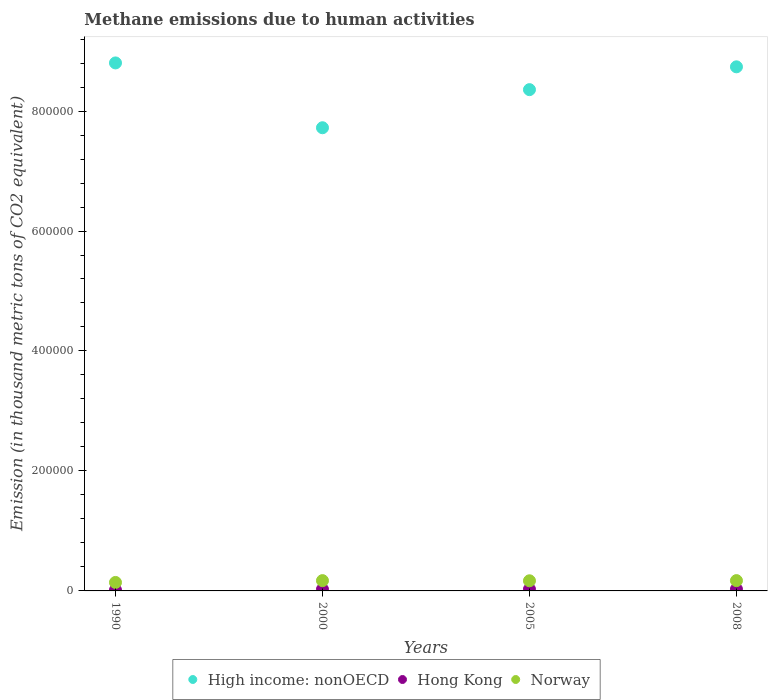How many different coloured dotlines are there?
Offer a terse response. 3. What is the amount of methane emitted in Norway in 2005?
Offer a terse response. 1.69e+04. Across all years, what is the maximum amount of methane emitted in Norway?
Your answer should be compact. 1.72e+04. Across all years, what is the minimum amount of methane emitted in Hong Kong?
Offer a very short reply. 1532.1. In which year was the amount of methane emitted in Norway maximum?
Make the answer very short. 2008. In which year was the amount of methane emitted in Norway minimum?
Make the answer very short. 1990. What is the total amount of methane emitted in Norway in the graph?
Offer a very short reply. 6.53e+04. What is the difference between the amount of methane emitted in High income: nonOECD in 2005 and that in 2008?
Offer a very short reply. -3.80e+04. What is the difference between the amount of methane emitted in Norway in 2000 and the amount of methane emitted in Hong Kong in 2008?
Your answer should be compact. 1.42e+04. What is the average amount of methane emitted in High income: nonOECD per year?
Offer a very short reply. 8.40e+05. In the year 1990, what is the difference between the amount of methane emitted in Norway and amount of methane emitted in Hong Kong?
Keep it short and to the point. 1.26e+04. In how many years, is the amount of methane emitted in High income: nonOECD greater than 560000 thousand metric tons?
Your answer should be compact. 4. What is the ratio of the amount of methane emitted in Hong Kong in 1990 to that in 2000?
Your answer should be very brief. 0.57. Is the amount of methane emitted in Norway in 2000 less than that in 2008?
Provide a succinct answer. Yes. Is the difference between the amount of methane emitted in Norway in 1990 and 2000 greater than the difference between the amount of methane emitted in Hong Kong in 1990 and 2000?
Provide a succinct answer. No. What is the difference between the highest and the lowest amount of methane emitted in Norway?
Keep it short and to the point. 3050.8. In how many years, is the amount of methane emitted in Hong Kong greater than the average amount of methane emitted in Hong Kong taken over all years?
Keep it short and to the point. 3. Is the sum of the amount of methane emitted in High income: nonOECD in 1990 and 2005 greater than the maximum amount of methane emitted in Hong Kong across all years?
Give a very brief answer. Yes. Is it the case that in every year, the sum of the amount of methane emitted in High income: nonOECD and amount of methane emitted in Norway  is greater than the amount of methane emitted in Hong Kong?
Your answer should be very brief. Yes. Is the amount of methane emitted in Norway strictly greater than the amount of methane emitted in Hong Kong over the years?
Your answer should be very brief. Yes. Is the amount of methane emitted in Hong Kong strictly less than the amount of methane emitted in Norway over the years?
Provide a succinct answer. Yes. How many dotlines are there?
Your answer should be very brief. 3. What is the difference between two consecutive major ticks on the Y-axis?
Offer a very short reply. 2.00e+05. Are the values on the major ticks of Y-axis written in scientific E-notation?
Keep it short and to the point. No. How many legend labels are there?
Your answer should be compact. 3. What is the title of the graph?
Provide a succinct answer. Methane emissions due to human activities. Does "Fragile and conflict affected situations" appear as one of the legend labels in the graph?
Keep it short and to the point. No. What is the label or title of the X-axis?
Your answer should be compact. Years. What is the label or title of the Y-axis?
Your answer should be compact. Emission (in thousand metric tons of CO2 equivalent). What is the Emission (in thousand metric tons of CO2 equivalent) in High income: nonOECD in 1990?
Make the answer very short. 8.80e+05. What is the Emission (in thousand metric tons of CO2 equivalent) of Hong Kong in 1990?
Offer a very short reply. 1532.1. What is the Emission (in thousand metric tons of CO2 equivalent) in Norway in 1990?
Ensure brevity in your answer.  1.41e+04. What is the Emission (in thousand metric tons of CO2 equivalent) of High income: nonOECD in 2000?
Your answer should be very brief. 7.72e+05. What is the Emission (in thousand metric tons of CO2 equivalent) in Hong Kong in 2000?
Keep it short and to the point. 2694.6. What is the Emission (in thousand metric tons of CO2 equivalent) in Norway in 2000?
Your response must be concise. 1.72e+04. What is the Emission (in thousand metric tons of CO2 equivalent) of High income: nonOECD in 2005?
Provide a short and direct response. 8.36e+05. What is the Emission (in thousand metric tons of CO2 equivalent) of Hong Kong in 2005?
Offer a very short reply. 2825. What is the Emission (in thousand metric tons of CO2 equivalent) in Norway in 2005?
Your response must be concise. 1.69e+04. What is the Emission (in thousand metric tons of CO2 equivalent) in High income: nonOECD in 2008?
Ensure brevity in your answer.  8.74e+05. What is the Emission (in thousand metric tons of CO2 equivalent) of Hong Kong in 2008?
Your answer should be very brief. 2976.8. What is the Emission (in thousand metric tons of CO2 equivalent) of Norway in 2008?
Give a very brief answer. 1.72e+04. Across all years, what is the maximum Emission (in thousand metric tons of CO2 equivalent) in High income: nonOECD?
Provide a succinct answer. 8.80e+05. Across all years, what is the maximum Emission (in thousand metric tons of CO2 equivalent) of Hong Kong?
Provide a short and direct response. 2976.8. Across all years, what is the maximum Emission (in thousand metric tons of CO2 equivalent) in Norway?
Your answer should be very brief. 1.72e+04. Across all years, what is the minimum Emission (in thousand metric tons of CO2 equivalent) in High income: nonOECD?
Ensure brevity in your answer.  7.72e+05. Across all years, what is the minimum Emission (in thousand metric tons of CO2 equivalent) of Hong Kong?
Offer a terse response. 1532.1. Across all years, what is the minimum Emission (in thousand metric tons of CO2 equivalent) in Norway?
Ensure brevity in your answer.  1.41e+04. What is the total Emission (in thousand metric tons of CO2 equivalent) in High income: nonOECD in the graph?
Provide a short and direct response. 3.36e+06. What is the total Emission (in thousand metric tons of CO2 equivalent) in Hong Kong in the graph?
Give a very brief answer. 1.00e+04. What is the total Emission (in thousand metric tons of CO2 equivalent) of Norway in the graph?
Ensure brevity in your answer.  6.53e+04. What is the difference between the Emission (in thousand metric tons of CO2 equivalent) in High income: nonOECD in 1990 and that in 2000?
Ensure brevity in your answer.  1.08e+05. What is the difference between the Emission (in thousand metric tons of CO2 equivalent) of Hong Kong in 1990 and that in 2000?
Offer a terse response. -1162.5. What is the difference between the Emission (in thousand metric tons of CO2 equivalent) of Norway in 1990 and that in 2000?
Provide a short and direct response. -3029.8. What is the difference between the Emission (in thousand metric tons of CO2 equivalent) in High income: nonOECD in 1990 and that in 2005?
Offer a terse response. 4.45e+04. What is the difference between the Emission (in thousand metric tons of CO2 equivalent) in Hong Kong in 1990 and that in 2005?
Ensure brevity in your answer.  -1292.9. What is the difference between the Emission (in thousand metric tons of CO2 equivalent) in Norway in 1990 and that in 2005?
Make the answer very short. -2775. What is the difference between the Emission (in thousand metric tons of CO2 equivalent) of High income: nonOECD in 1990 and that in 2008?
Offer a very short reply. 6496.2. What is the difference between the Emission (in thousand metric tons of CO2 equivalent) of Hong Kong in 1990 and that in 2008?
Give a very brief answer. -1444.7. What is the difference between the Emission (in thousand metric tons of CO2 equivalent) in Norway in 1990 and that in 2008?
Offer a terse response. -3050.8. What is the difference between the Emission (in thousand metric tons of CO2 equivalent) of High income: nonOECD in 2000 and that in 2005?
Your answer should be very brief. -6.35e+04. What is the difference between the Emission (in thousand metric tons of CO2 equivalent) of Hong Kong in 2000 and that in 2005?
Provide a succinct answer. -130.4. What is the difference between the Emission (in thousand metric tons of CO2 equivalent) of Norway in 2000 and that in 2005?
Offer a terse response. 254.8. What is the difference between the Emission (in thousand metric tons of CO2 equivalent) of High income: nonOECD in 2000 and that in 2008?
Offer a terse response. -1.02e+05. What is the difference between the Emission (in thousand metric tons of CO2 equivalent) of Hong Kong in 2000 and that in 2008?
Keep it short and to the point. -282.2. What is the difference between the Emission (in thousand metric tons of CO2 equivalent) in High income: nonOECD in 2005 and that in 2008?
Provide a short and direct response. -3.80e+04. What is the difference between the Emission (in thousand metric tons of CO2 equivalent) of Hong Kong in 2005 and that in 2008?
Your answer should be compact. -151.8. What is the difference between the Emission (in thousand metric tons of CO2 equivalent) of Norway in 2005 and that in 2008?
Offer a terse response. -275.8. What is the difference between the Emission (in thousand metric tons of CO2 equivalent) in High income: nonOECD in 1990 and the Emission (in thousand metric tons of CO2 equivalent) in Hong Kong in 2000?
Your answer should be compact. 8.78e+05. What is the difference between the Emission (in thousand metric tons of CO2 equivalent) in High income: nonOECD in 1990 and the Emission (in thousand metric tons of CO2 equivalent) in Norway in 2000?
Provide a succinct answer. 8.63e+05. What is the difference between the Emission (in thousand metric tons of CO2 equivalent) of Hong Kong in 1990 and the Emission (in thousand metric tons of CO2 equivalent) of Norway in 2000?
Your answer should be compact. -1.56e+04. What is the difference between the Emission (in thousand metric tons of CO2 equivalent) of High income: nonOECD in 1990 and the Emission (in thousand metric tons of CO2 equivalent) of Hong Kong in 2005?
Offer a very short reply. 8.77e+05. What is the difference between the Emission (in thousand metric tons of CO2 equivalent) of High income: nonOECD in 1990 and the Emission (in thousand metric tons of CO2 equivalent) of Norway in 2005?
Provide a short and direct response. 8.63e+05. What is the difference between the Emission (in thousand metric tons of CO2 equivalent) of Hong Kong in 1990 and the Emission (in thousand metric tons of CO2 equivalent) of Norway in 2005?
Offer a very short reply. -1.54e+04. What is the difference between the Emission (in thousand metric tons of CO2 equivalent) of High income: nonOECD in 1990 and the Emission (in thousand metric tons of CO2 equivalent) of Hong Kong in 2008?
Ensure brevity in your answer.  8.77e+05. What is the difference between the Emission (in thousand metric tons of CO2 equivalent) in High income: nonOECD in 1990 and the Emission (in thousand metric tons of CO2 equivalent) in Norway in 2008?
Offer a terse response. 8.63e+05. What is the difference between the Emission (in thousand metric tons of CO2 equivalent) in Hong Kong in 1990 and the Emission (in thousand metric tons of CO2 equivalent) in Norway in 2008?
Your answer should be very brief. -1.56e+04. What is the difference between the Emission (in thousand metric tons of CO2 equivalent) of High income: nonOECD in 2000 and the Emission (in thousand metric tons of CO2 equivalent) of Hong Kong in 2005?
Your answer should be compact. 7.69e+05. What is the difference between the Emission (in thousand metric tons of CO2 equivalent) of High income: nonOECD in 2000 and the Emission (in thousand metric tons of CO2 equivalent) of Norway in 2005?
Your response must be concise. 7.55e+05. What is the difference between the Emission (in thousand metric tons of CO2 equivalent) of Hong Kong in 2000 and the Emission (in thousand metric tons of CO2 equivalent) of Norway in 2005?
Provide a short and direct response. -1.42e+04. What is the difference between the Emission (in thousand metric tons of CO2 equivalent) in High income: nonOECD in 2000 and the Emission (in thousand metric tons of CO2 equivalent) in Hong Kong in 2008?
Give a very brief answer. 7.69e+05. What is the difference between the Emission (in thousand metric tons of CO2 equivalent) of High income: nonOECD in 2000 and the Emission (in thousand metric tons of CO2 equivalent) of Norway in 2008?
Ensure brevity in your answer.  7.55e+05. What is the difference between the Emission (in thousand metric tons of CO2 equivalent) in Hong Kong in 2000 and the Emission (in thousand metric tons of CO2 equivalent) in Norway in 2008?
Your response must be concise. -1.45e+04. What is the difference between the Emission (in thousand metric tons of CO2 equivalent) in High income: nonOECD in 2005 and the Emission (in thousand metric tons of CO2 equivalent) in Hong Kong in 2008?
Your answer should be very brief. 8.33e+05. What is the difference between the Emission (in thousand metric tons of CO2 equivalent) in High income: nonOECD in 2005 and the Emission (in thousand metric tons of CO2 equivalent) in Norway in 2008?
Ensure brevity in your answer.  8.18e+05. What is the difference between the Emission (in thousand metric tons of CO2 equivalent) of Hong Kong in 2005 and the Emission (in thousand metric tons of CO2 equivalent) of Norway in 2008?
Your answer should be compact. -1.43e+04. What is the average Emission (in thousand metric tons of CO2 equivalent) of High income: nonOECD per year?
Keep it short and to the point. 8.40e+05. What is the average Emission (in thousand metric tons of CO2 equivalent) of Hong Kong per year?
Ensure brevity in your answer.  2507.12. What is the average Emission (in thousand metric tons of CO2 equivalent) of Norway per year?
Keep it short and to the point. 1.63e+04. In the year 1990, what is the difference between the Emission (in thousand metric tons of CO2 equivalent) of High income: nonOECD and Emission (in thousand metric tons of CO2 equivalent) of Hong Kong?
Your answer should be compact. 8.79e+05. In the year 1990, what is the difference between the Emission (in thousand metric tons of CO2 equivalent) of High income: nonOECD and Emission (in thousand metric tons of CO2 equivalent) of Norway?
Provide a short and direct response. 8.66e+05. In the year 1990, what is the difference between the Emission (in thousand metric tons of CO2 equivalent) in Hong Kong and Emission (in thousand metric tons of CO2 equivalent) in Norway?
Your response must be concise. -1.26e+04. In the year 2000, what is the difference between the Emission (in thousand metric tons of CO2 equivalent) in High income: nonOECD and Emission (in thousand metric tons of CO2 equivalent) in Hong Kong?
Provide a short and direct response. 7.69e+05. In the year 2000, what is the difference between the Emission (in thousand metric tons of CO2 equivalent) in High income: nonOECD and Emission (in thousand metric tons of CO2 equivalent) in Norway?
Make the answer very short. 7.55e+05. In the year 2000, what is the difference between the Emission (in thousand metric tons of CO2 equivalent) in Hong Kong and Emission (in thousand metric tons of CO2 equivalent) in Norway?
Offer a terse response. -1.45e+04. In the year 2005, what is the difference between the Emission (in thousand metric tons of CO2 equivalent) of High income: nonOECD and Emission (in thousand metric tons of CO2 equivalent) of Hong Kong?
Make the answer very short. 8.33e+05. In the year 2005, what is the difference between the Emission (in thousand metric tons of CO2 equivalent) in High income: nonOECD and Emission (in thousand metric tons of CO2 equivalent) in Norway?
Make the answer very short. 8.19e+05. In the year 2005, what is the difference between the Emission (in thousand metric tons of CO2 equivalent) in Hong Kong and Emission (in thousand metric tons of CO2 equivalent) in Norway?
Offer a very short reply. -1.41e+04. In the year 2008, what is the difference between the Emission (in thousand metric tons of CO2 equivalent) in High income: nonOECD and Emission (in thousand metric tons of CO2 equivalent) in Hong Kong?
Make the answer very short. 8.71e+05. In the year 2008, what is the difference between the Emission (in thousand metric tons of CO2 equivalent) of High income: nonOECD and Emission (in thousand metric tons of CO2 equivalent) of Norway?
Provide a succinct answer. 8.57e+05. In the year 2008, what is the difference between the Emission (in thousand metric tons of CO2 equivalent) in Hong Kong and Emission (in thousand metric tons of CO2 equivalent) in Norway?
Make the answer very short. -1.42e+04. What is the ratio of the Emission (in thousand metric tons of CO2 equivalent) of High income: nonOECD in 1990 to that in 2000?
Offer a very short reply. 1.14. What is the ratio of the Emission (in thousand metric tons of CO2 equivalent) of Hong Kong in 1990 to that in 2000?
Offer a very short reply. 0.57. What is the ratio of the Emission (in thousand metric tons of CO2 equivalent) of Norway in 1990 to that in 2000?
Make the answer very short. 0.82. What is the ratio of the Emission (in thousand metric tons of CO2 equivalent) in High income: nonOECD in 1990 to that in 2005?
Offer a very short reply. 1.05. What is the ratio of the Emission (in thousand metric tons of CO2 equivalent) in Hong Kong in 1990 to that in 2005?
Offer a very short reply. 0.54. What is the ratio of the Emission (in thousand metric tons of CO2 equivalent) of Norway in 1990 to that in 2005?
Your answer should be very brief. 0.84. What is the ratio of the Emission (in thousand metric tons of CO2 equivalent) in High income: nonOECD in 1990 to that in 2008?
Offer a very short reply. 1.01. What is the ratio of the Emission (in thousand metric tons of CO2 equivalent) in Hong Kong in 1990 to that in 2008?
Make the answer very short. 0.51. What is the ratio of the Emission (in thousand metric tons of CO2 equivalent) in Norway in 1990 to that in 2008?
Your answer should be compact. 0.82. What is the ratio of the Emission (in thousand metric tons of CO2 equivalent) in High income: nonOECD in 2000 to that in 2005?
Your response must be concise. 0.92. What is the ratio of the Emission (in thousand metric tons of CO2 equivalent) in Hong Kong in 2000 to that in 2005?
Your answer should be compact. 0.95. What is the ratio of the Emission (in thousand metric tons of CO2 equivalent) of Norway in 2000 to that in 2005?
Your answer should be very brief. 1.02. What is the ratio of the Emission (in thousand metric tons of CO2 equivalent) in High income: nonOECD in 2000 to that in 2008?
Your answer should be compact. 0.88. What is the ratio of the Emission (in thousand metric tons of CO2 equivalent) of Hong Kong in 2000 to that in 2008?
Your answer should be compact. 0.91. What is the ratio of the Emission (in thousand metric tons of CO2 equivalent) in High income: nonOECD in 2005 to that in 2008?
Keep it short and to the point. 0.96. What is the ratio of the Emission (in thousand metric tons of CO2 equivalent) of Hong Kong in 2005 to that in 2008?
Ensure brevity in your answer.  0.95. What is the ratio of the Emission (in thousand metric tons of CO2 equivalent) in Norway in 2005 to that in 2008?
Offer a very short reply. 0.98. What is the difference between the highest and the second highest Emission (in thousand metric tons of CO2 equivalent) of High income: nonOECD?
Give a very brief answer. 6496.2. What is the difference between the highest and the second highest Emission (in thousand metric tons of CO2 equivalent) of Hong Kong?
Your answer should be very brief. 151.8. What is the difference between the highest and the lowest Emission (in thousand metric tons of CO2 equivalent) in High income: nonOECD?
Make the answer very short. 1.08e+05. What is the difference between the highest and the lowest Emission (in thousand metric tons of CO2 equivalent) of Hong Kong?
Your response must be concise. 1444.7. What is the difference between the highest and the lowest Emission (in thousand metric tons of CO2 equivalent) of Norway?
Your response must be concise. 3050.8. 